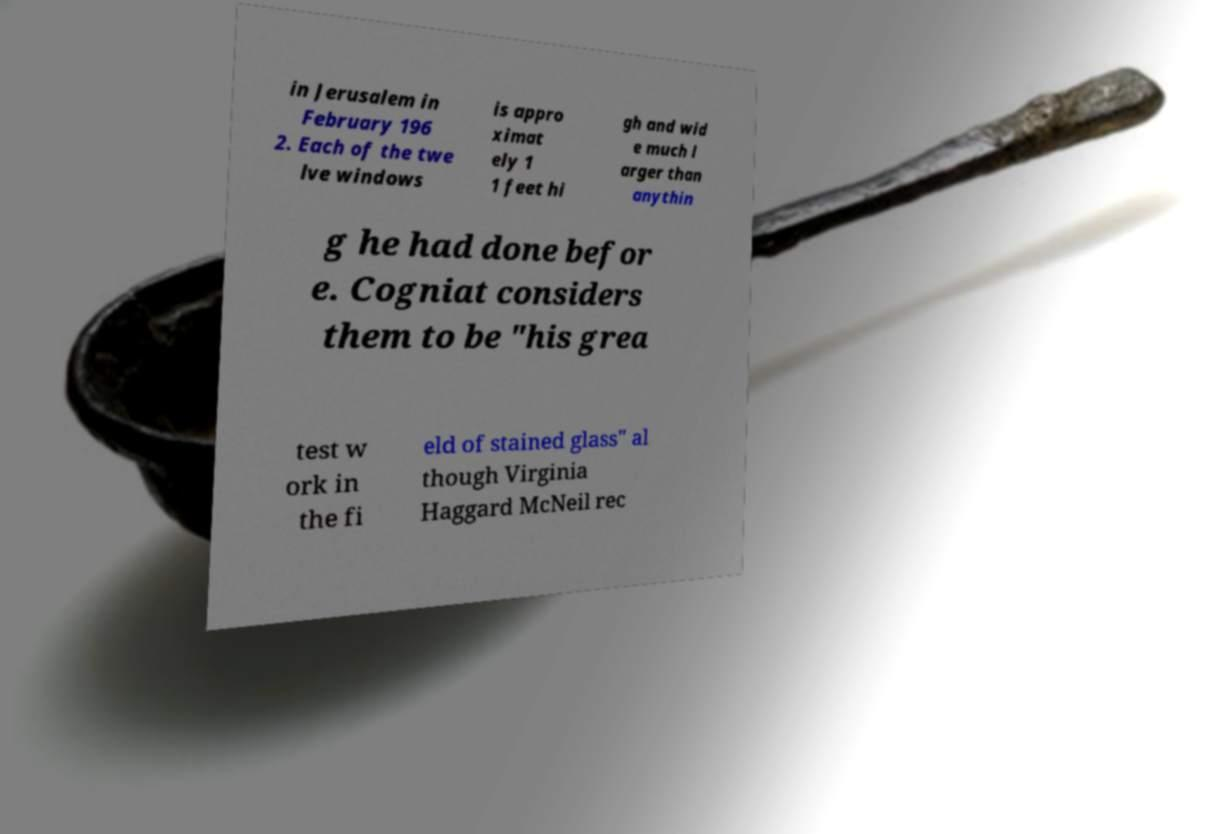Please read and relay the text visible in this image. What does it say? in Jerusalem in February 196 2. Each of the twe lve windows is appro ximat ely 1 1 feet hi gh and wid e much l arger than anythin g he had done befor e. Cogniat considers them to be "his grea test w ork in the fi eld of stained glass" al though Virginia Haggard McNeil rec 